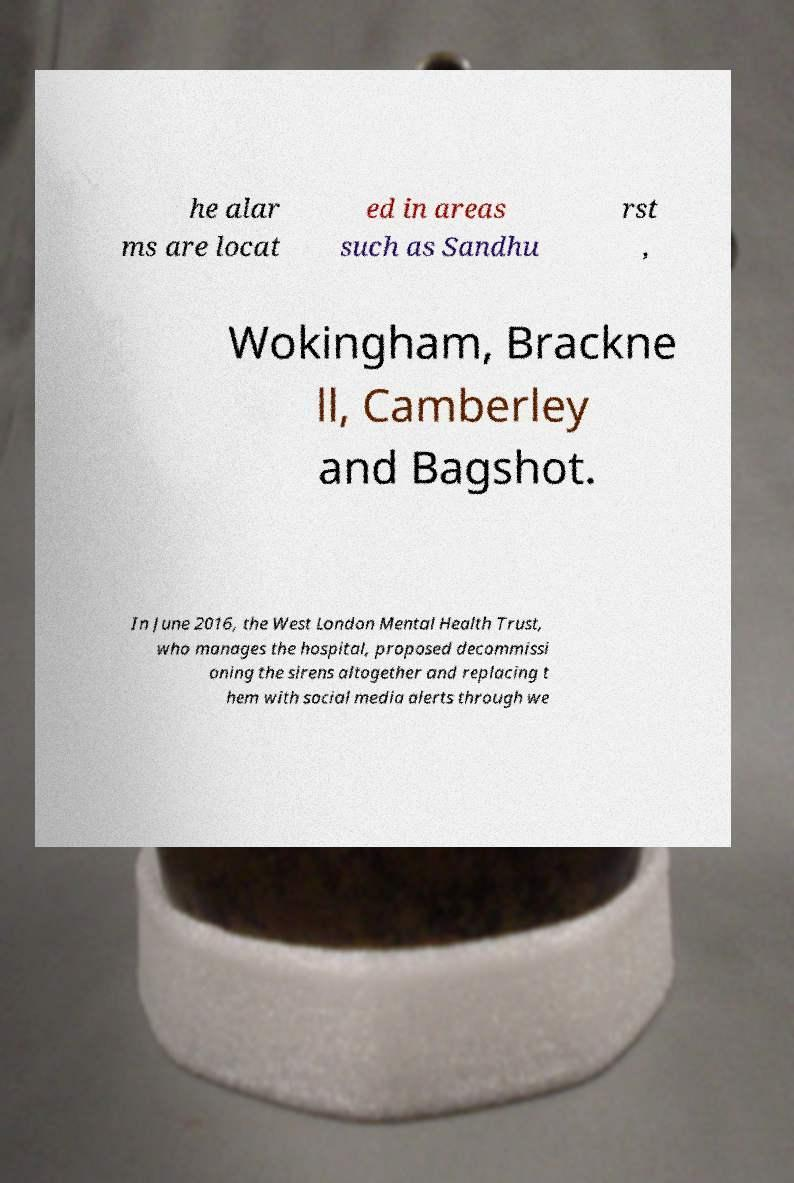I need the written content from this picture converted into text. Can you do that? he alar ms are locat ed in areas such as Sandhu rst , Wokingham, Brackne ll, Camberley and Bagshot. In June 2016, the West London Mental Health Trust, who manages the hospital, proposed decommissi oning the sirens altogether and replacing t hem with social media alerts through we 